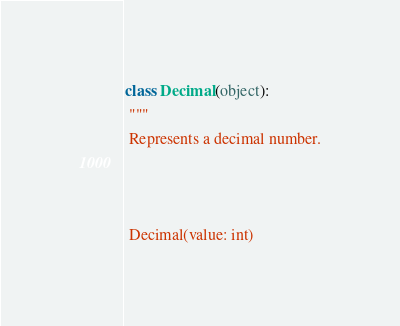<code> <loc_0><loc_0><loc_500><loc_500><_Python_>class Decimal(object):
 """
 Represents a decimal number.
 
 Decimal(value: int)</code> 